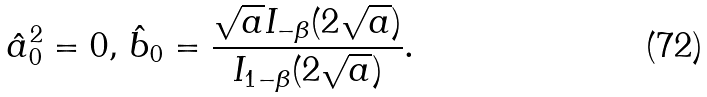<formula> <loc_0><loc_0><loc_500><loc_500>\hat { a } _ { 0 } ^ { 2 } = 0 , \, { \hat { b } } _ { 0 } = \frac { \sqrt { a } I _ { - \beta } ( 2 \sqrt { a } ) } { I _ { 1 - \beta } ( 2 \sqrt { a } ) } .</formula> 